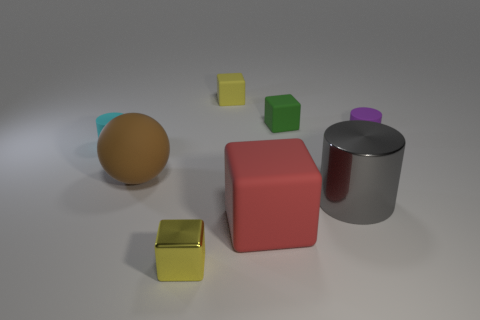There is a matte block that is the same color as the tiny shiny thing; what is its size?
Your answer should be compact. Small. How many things are large red blocks or large brown balls?
Offer a terse response. 2. There is a big brown rubber thing in front of the tiny thing that is on the left side of the large brown ball; what is its shape?
Give a very brief answer. Sphere. There is a object on the left side of the brown matte sphere; does it have the same shape as the tiny yellow metallic object?
Provide a short and direct response. No. What is the size of the yellow block that is made of the same material as the large cylinder?
Your answer should be compact. Small. What number of objects are either tiny cubes behind the large matte sphere or tiny yellow metal cubes on the left side of the large gray thing?
Give a very brief answer. 3. Is the number of tiny green matte things behind the tiny green block the same as the number of tiny yellow rubber objects in front of the tiny yellow shiny cube?
Keep it short and to the point. Yes. What color is the matte block in front of the brown thing?
Your answer should be very brief. Red. Is the color of the small metal cube the same as the block that is behind the tiny green thing?
Keep it short and to the point. Yes. Is the number of tiny yellow cubes less than the number of large red cubes?
Offer a very short reply. No. 